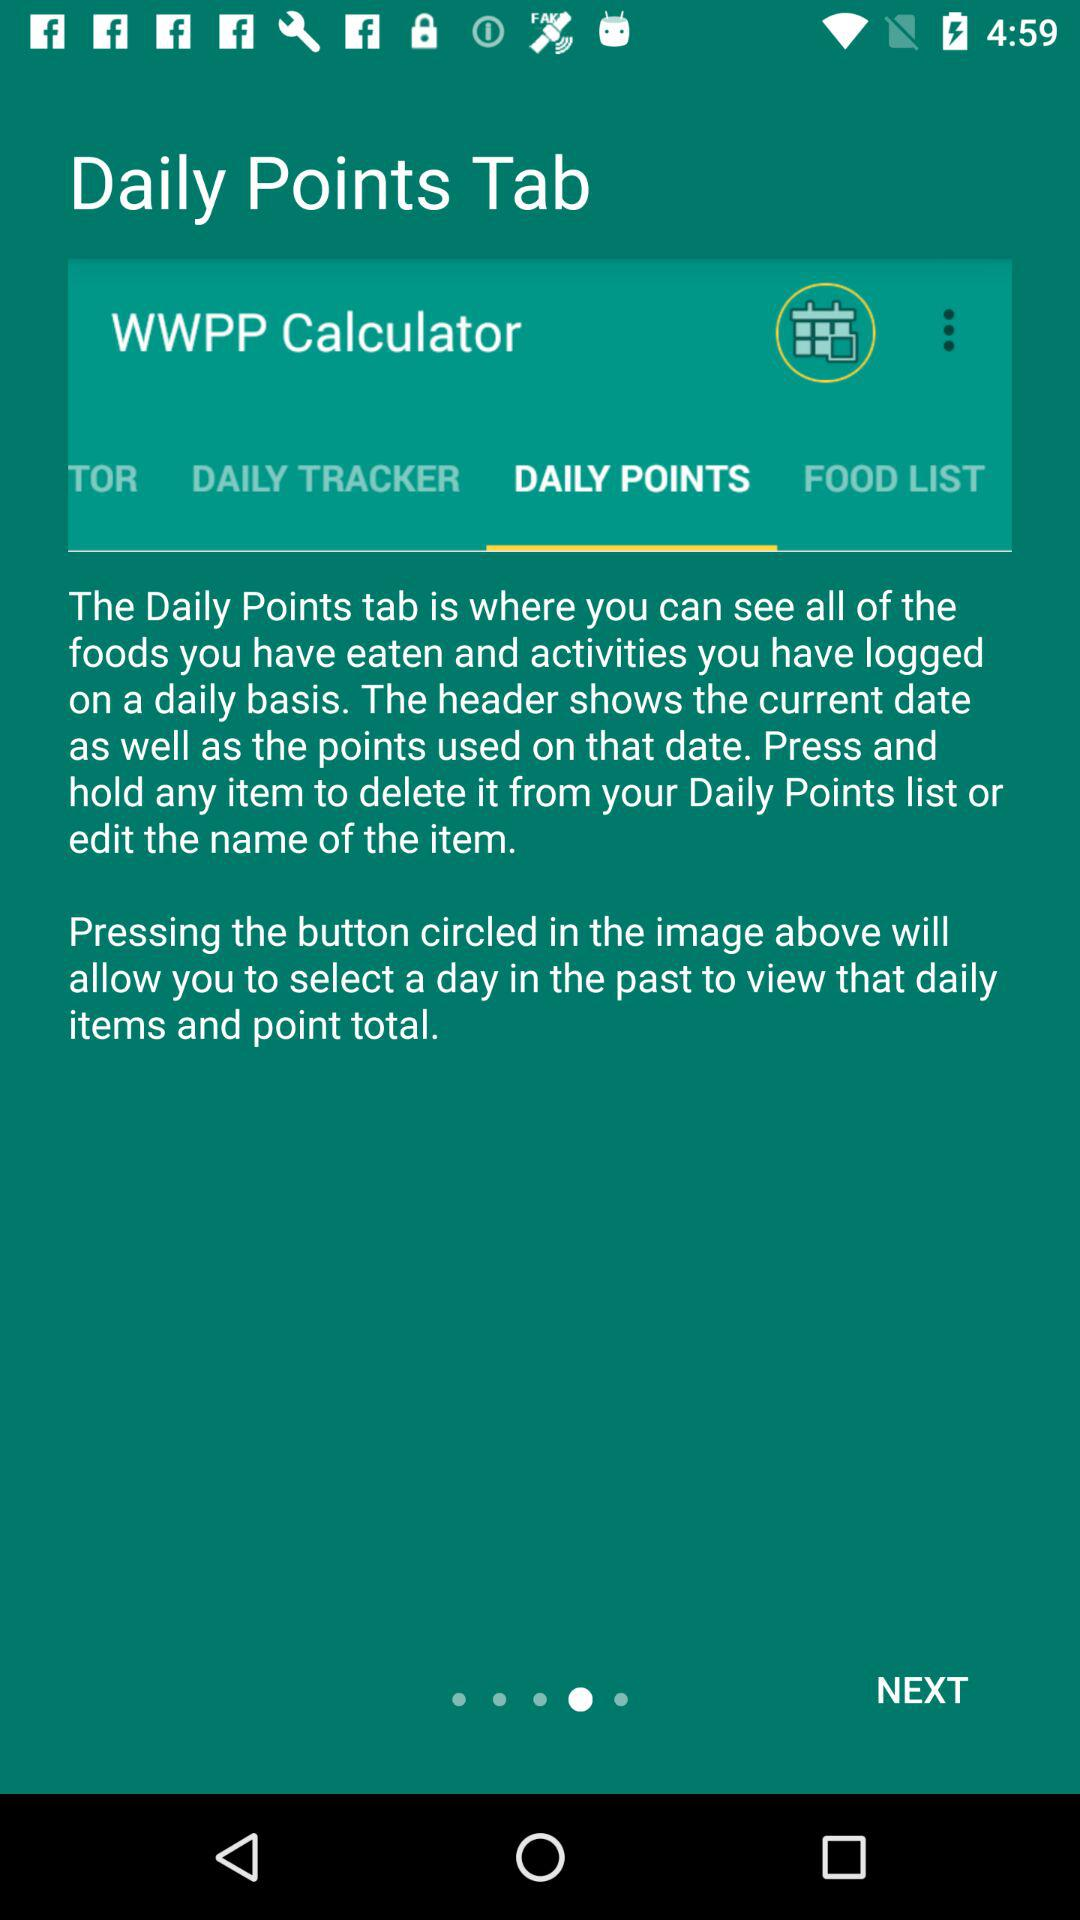What is the name of application?
When the provided information is insufficient, respond with <no answer>. <no answer> 